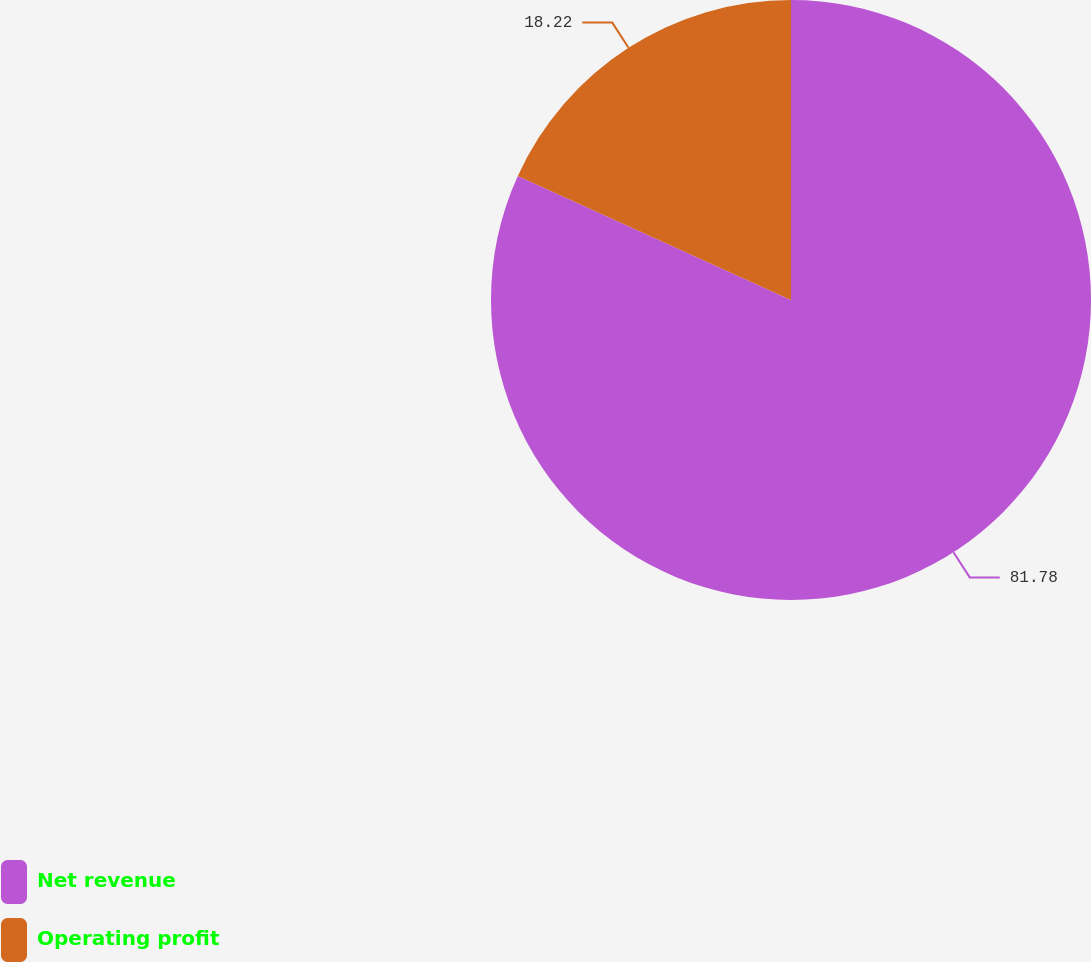<chart> <loc_0><loc_0><loc_500><loc_500><pie_chart><fcel>Net revenue<fcel>Operating profit<nl><fcel>81.78%<fcel>18.22%<nl></chart> 